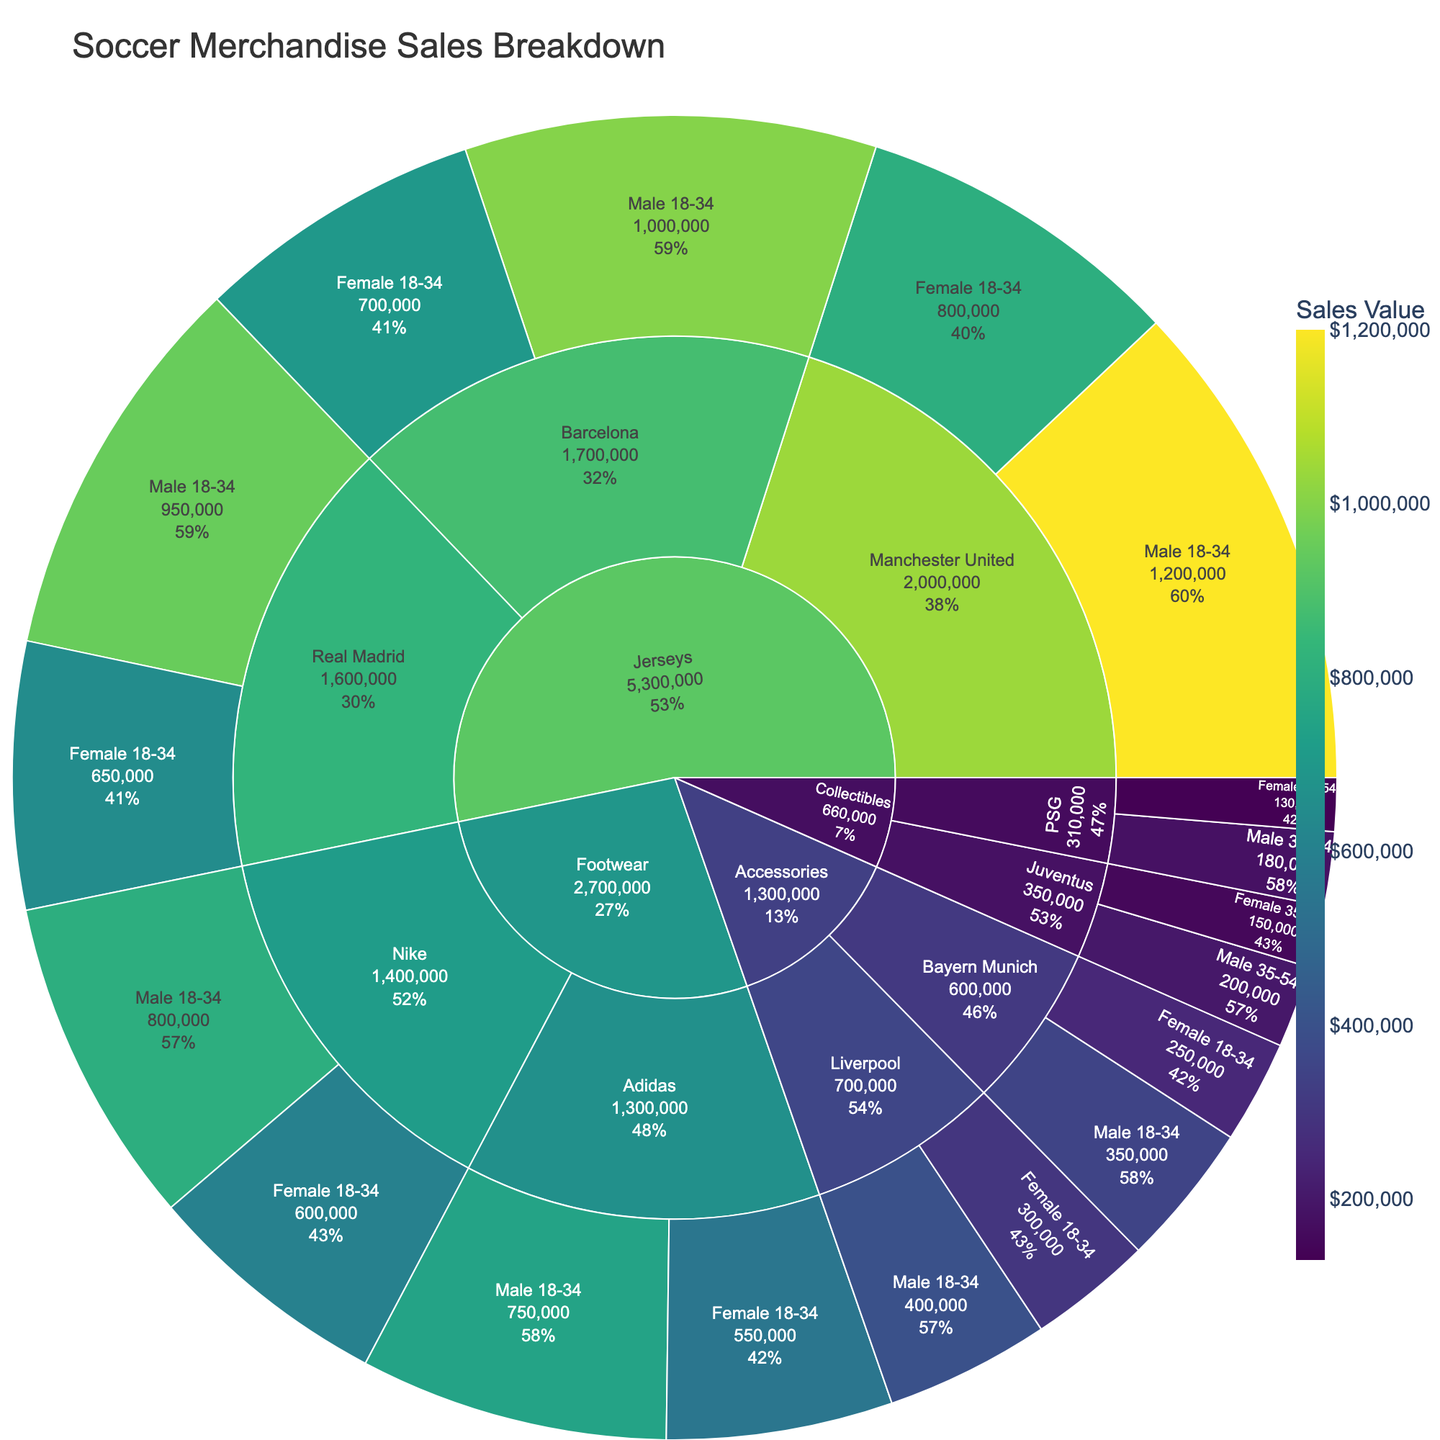What's the title of the plot? The plot title is displayed prominently at the top of the figure.
Answer: Soccer Merchandise Sales Breakdown How many different product categories are represented in the sunburst plot? The plot segments reveal the different product categories which are the outermost labels. There are four categories visible: Jerseys, Footwear, Accessories, and Collectibles.
Answer: 4 Which team has the highest sales value in the 'Jerseys' category? By looking at the sunburst segment for 'Jerseys' and comparing team sales, Manchester United has the highest values (for both demographics combined).
Answer: Manchester United What is the total sales value for Nike in the 'Footwear' category? Nike's sales for 'Footwear' can be observed in the plot. Summing up the values for both demographics (Male 18-34, Female 18-34): 800,000 (Males) + 600,000 (Females) = 1,400,000.
Answer: $1,400,000 Which gender demographic has higher sales for 'Collectibles' affiliated with PSG? By examining the 'Collectibles' segment for PSG, you can compare the sales values for Male 35-54 and Female 35-54 groups. Males have higher sales (180,000 vs. 130,000).
Answer: Male 35-54 In 'Accessories', which team has the lowest sales value and what is it? From the 'Accessories' segment, by comparing sales values: Bayern Munich has the lowest sales value, with totals of 350,000 (Males) + 250,000 (Females) = 600,000.
Answer: Bayern Munich, $600,000 What is the total sales value for female customers aged 18-34 across all 'Jerseys' teams? Summing the female 18-34 sales for all 'Jerseys' teams: 800,000 (Manchester United) + 700,000 (Barcelona) + 650,000 (Real Madrid) = 2,150,000.
Answer: $2,150,000 Which product and team combination has the highest total sales value? By looking at all segments, we can compare the total values. The 'Jerseys' for Manchester United (total of male and female 18-34) has the highest sales value: 1,200,000 + 800,000 = 2,000,000.
Answer: Jerseys, Manchester United Compare the sales of 'Footwear' under Adidas to 'Accessories' under Liverpool. Which is higher and by how much? For 'Footwear' under Adidas: 750,000 (Males) + 550,000 (Females) = 1,300,000. For 'Accessories' under Liverpool: 400,000 (Males) + 300,000 (Females) = 700,000. Difference: 1,300,000 - 700,000 = 600,000.
Answer: Footwear (Adidas), $600,000 What percentage of total 'Collectibles' sales does Juventus account for? Summing all 'Collectibles' sales: 200,000 (Male 35-54, Juventus) + 150,000 (Female 35-54, Juventus) + 180,000 (Male 35-54, PSG) + 130,000 (Female 35-54, PSG) = 660,000. Percentage: (200,000 + 150,000) / 660,000 * 100% ≈ 53%.
Answer: 53% 